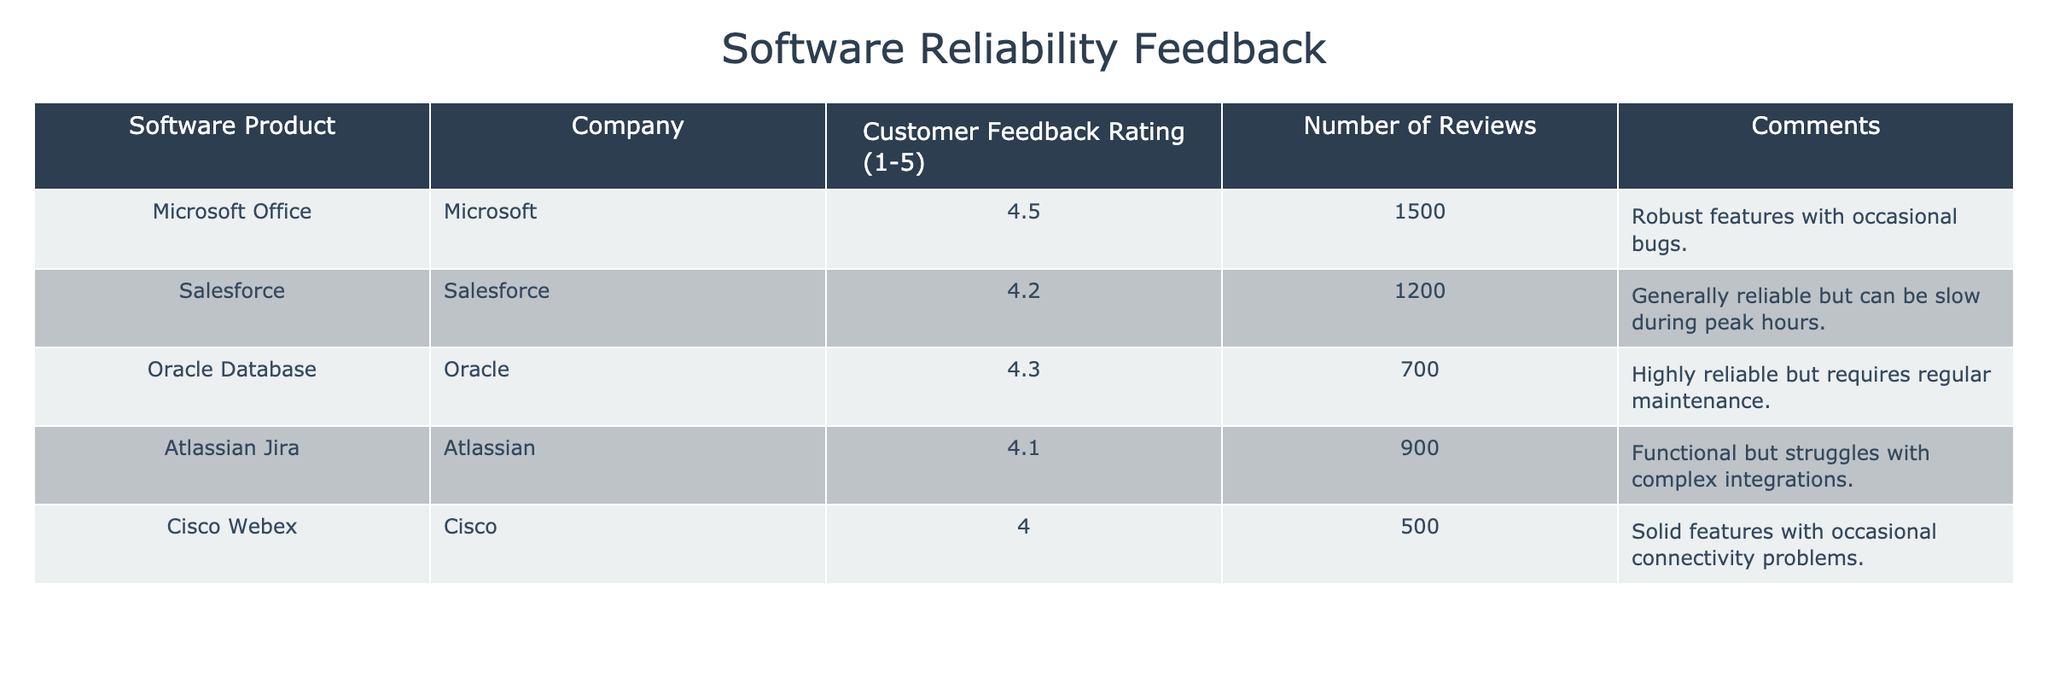What is the highest customer feedback rating among the software products? The customer feedback ratings are 4.5 for Microsoft Office, 4.2 for Salesforce, 4.3 for Oracle Database, 4.1 for Atlassian Jira, and 4.0 for Cisco Webex. The highest of these is 4.5 for Microsoft Office.
Answer: 4.5 How many total reviews were submitted for all software products? The number of reviews for each software product are 1500 (Microsoft Office), 1200 (Salesforce), 700 (Oracle Database), 900 (Atlassian Jira), and 500 (Cisco Webex). Adding these gives a total of 1500 + 1200 + 700 + 900 + 500 = 3800 reviews.
Answer: 3800 Is Oracle Database rated higher than Salesforce? Oracle Database has a customer feedback rating of 4.3, while Salesforce has a rating of 4.2. Since 4.3 is greater than 4.2, Oracle Database is rated higher than Salesforce.
Answer: Yes What is the average customer feedback rating for the three highest-rated software products? The highest ratings are 4.5 (Microsoft Office), 4.3 (Oracle Database), and 4.2 (Salesforce). Summing these ratings gives 4.5 + 4.3 + 4.2 = 13.0. There are three products, so the average is 13.0 / 3 = 4.33.
Answer: 4.33 Are there any products with a customer feedback rating lower than 4.0? The ratings for each product are: 4.5 (Microsoft Office), 4.2 (Salesforce), 4.3 (Oracle Database), 4.1 (Atlassian Jira), and 4.0 (Cisco Webex). Since there are no products rated below 4.0, the answer is no.
Answer: No Which company has received the lowest customer feedback rating? The ratings for the companies are as follows: Microsoft (4.5), Salesforce (4.2), Oracle (4.3), Atlassian (4.1), and Cisco (4.0). Cisco received the lowest rating, which is 4.0.
Answer: Cisco What percentage of reviews is contributed by Microsoft Office? Microsoft Office received 1500 reviews out of a total of 3800 reviews. To find the percentage, the calculation is (1500 / 3800) * 100 = 39.47%.
Answer: 39.47% Which software product has the maximum number of reviews, and what is that number? Review counts are as follows: 1500 for Microsoft Office, 1200 for Salesforce, 700 for Oracle Database, 900 for Atlassian Jira, and 500 for Cisco Webex. The maximum number of reviews belongs to Microsoft Office with 1500 reviews.
Answer: Microsoft Office, 1500 What rating did Atlassian Jira receive from customers? The table shows that Atlassian Jira has a customer feedback rating of 4.1. The answer is directly taken from the corresponding row in the table.
Answer: 4.1 